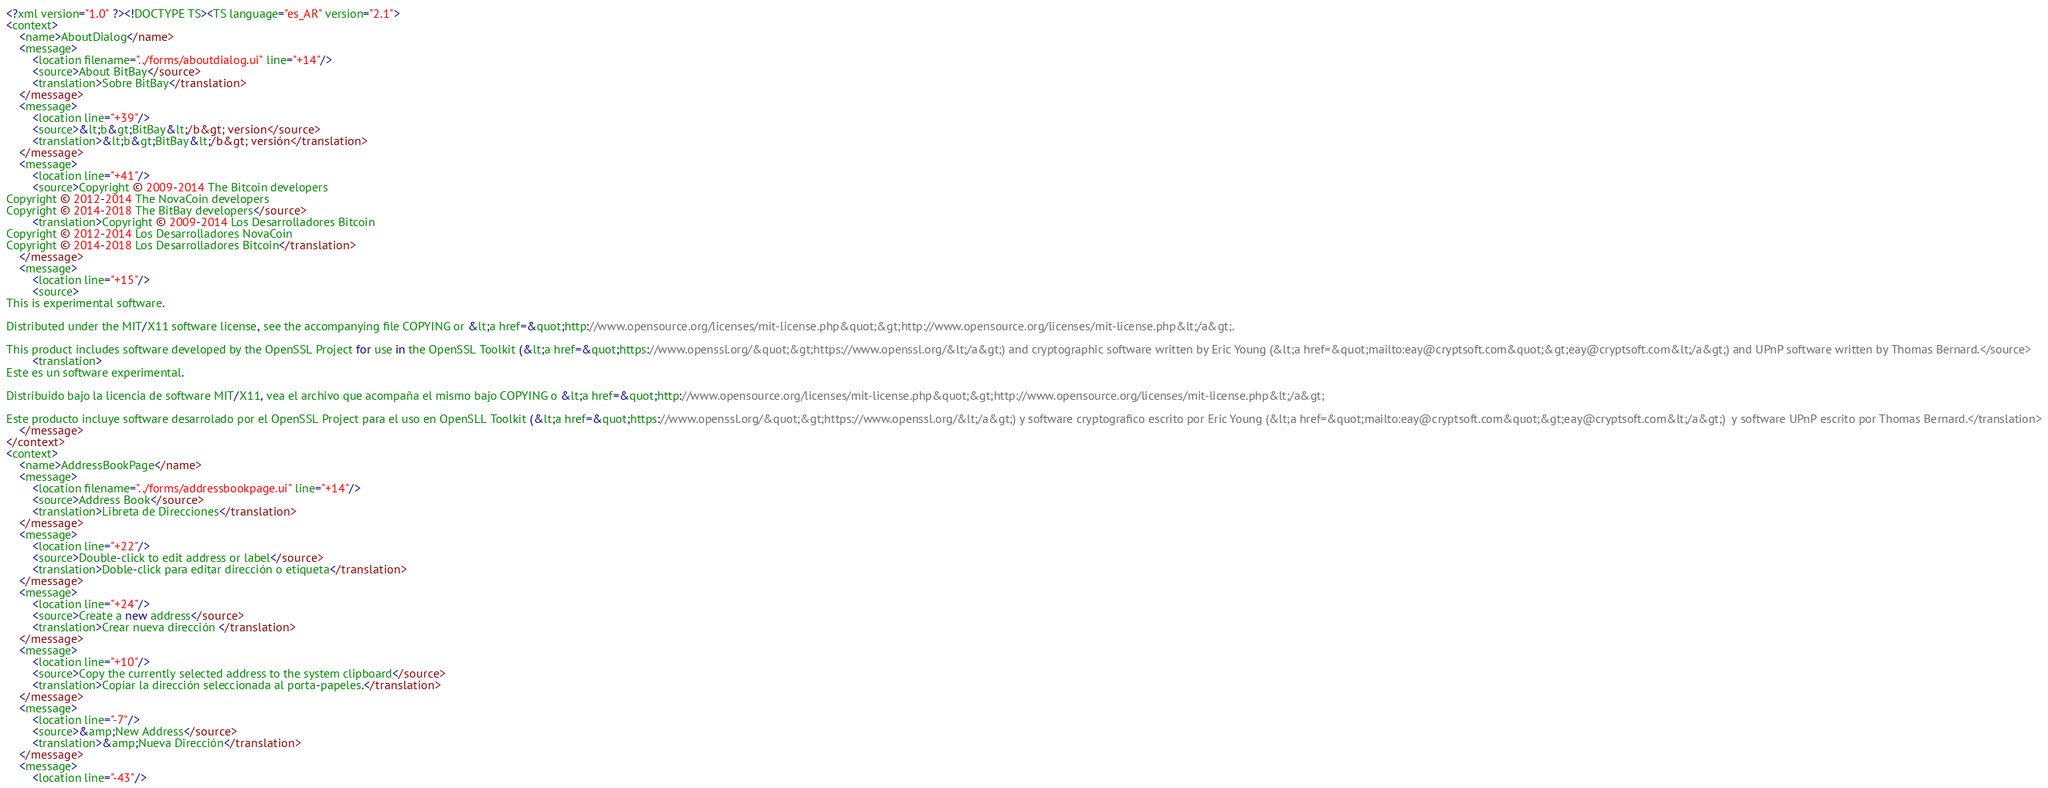Convert code to text. <code><loc_0><loc_0><loc_500><loc_500><_TypeScript_><?xml version="1.0" ?><!DOCTYPE TS><TS language="es_AR" version="2.1">
<context>
    <name>AboutDialog</name>
    <message>
        <location filename="../forms/aboutdialog.ui" line="+14"/>
        <source>About BitBay</source>
        <translation>Sobre BitBay</translation>
    </message>
    <message>
        <location line="+39"/>
        <source>&lt;b&gt;BitBay&lt;/b&gt; version</source>
        <translation>&lt;b&gt;BitBay&lt;/b&gt; versión</translation>
    </message>
    <message>
        <location line="+41"/>
        <source>Copyright © 2009-2014 The Bitcoin developers
Copyright © 2012-2014 The NovaCoin developers
Copyright © 2014-2018 The BitBay developers</source>
        <translation>Copyright © 2009-2014 Los Desarrolladores Bitcoin
Copyright © 2012-2014 Los Desarrolladores NovaCoin
Copyright © 2014-2018 Los Desarrolladores Bitcoin</translation>
    </message>
    <message>
        <location line="+15"/>
        <source>
This is experimental software.

Distributed under the MIT/X11 software license, see the accompanying file COPYING or &lt;a href=&quot;http://www.opensource.org/licenses/mit-license.php&quot;&gt;http://www.opensource.org/licenses/mit-license.php&lt;/a&gt;.

This product includes software developed by the OpenSSL Project for use in the OpenSSL Toolkit (&lt;a href=&quot;https://www.openssl.org/&quot;&gt;https://www.openssl.org/&lt;/a&gt;) and cryptographic software written by Eric Young (&lt;a href=&quot;mailto:eay@cryptsoft.com&quot;&gt;eay@cryptsoft.com&lt;/a&gt;) and UPnP software written by Thomas Bernard.</source>
        <translation>
Este es un software experimental.

Distribuido bajo la licencia de software MIT/X11, vea el archivo que acompaña el mismo bajo COPYING o &lt;a href=&quot;http://www.opensource.org/licenses/mit-license.php&quot;&gt;http://www.opensource.org/licenses/mit-license.php&lt;/a&gt;

Este producto incluye software desarrolado por el OpenSSL Project para el uso en OpenSLL Toolkit (&lt;a href=&quot;https://www.openssl.org/&quot;&gt;https://www.openssl.org/&lt;/a&gt;) y software cryptografico escrito por Eric Young (&lt;a href=&quot;mailto:eay@cryptsoft.com&quot;&gt;eay@cryptsoft.com&lt;/a&gt;)  y software UPnP escrito por Thomas Bernard.</translation>
    </message>
</context>
<context>
    <name>AddressBookPage</name>
    <message>
        <location filename="../forms/addressbookpage.ui" line="+14"/>
        <source>Address Book</source>
        <translation>Libreta de Direcciones</translation>
    </message>
    <message>
        <location line="+22"/>
        <source>Double-click to edit address or label</source>
        <translation>Doble-click para editar dirección o etiqueta</translation>
    </message>
    <message>
        <location line="+24"/>
        <source>Create a new address</source>
        <translation>Crear nueva dirección </translation>
    </message>
    <message>
        <location line="+10"/>
        <source>Copy the currently selected address to the system clipboard</source>
        <translation>Copiar la dirección seleccionada al porta-papeles.</translation>
    </message>
    <message>
        <location line="-7"/>
        <source>&amp;New Address</source>
        <translation>&amp;Nueva Dirección</translation>
    </message>
    <message>
        <location line="-43"/></code> 